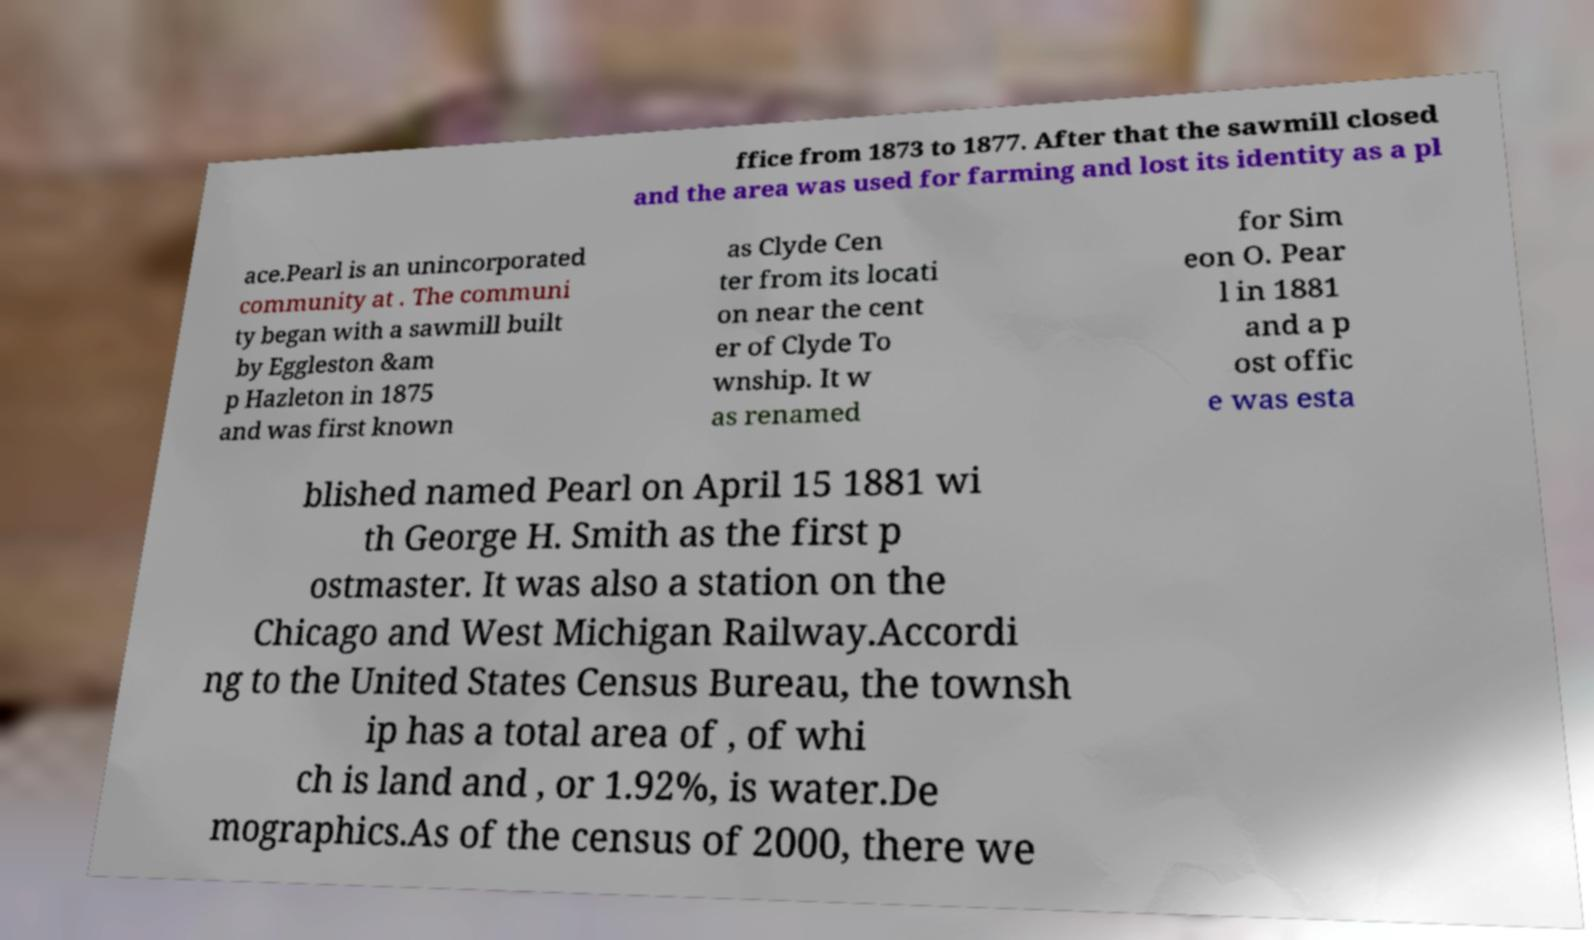Could you assist in decoding the text presented in this image and type it out clearly? ffice from 1873 to 1877. After that the sawmill closed and the area was used for farming and lost its identity as a pl ace.Pearl is an unincorporated community at . The communi ty began with a sawmill built by Eggleston &am p Hazleton in 1875 and was first known as Clyde Cen ter from its locati on near the cent er of Clyde To wnship. It w as renamed for Sim eon O. Pear l in 1881 and a p ost offic e was esta blished named Pearl on April 15 1881 wi th George H. Smith as the first p ostmaster. It was also a station on the Chicago and West Michigan Railway.Accordi ng to the United States Census Bureau, the townsh ip has a total area of , of whi ch is land and , or 1.92%, is water.De mographics.As of the census of 2000, there we 